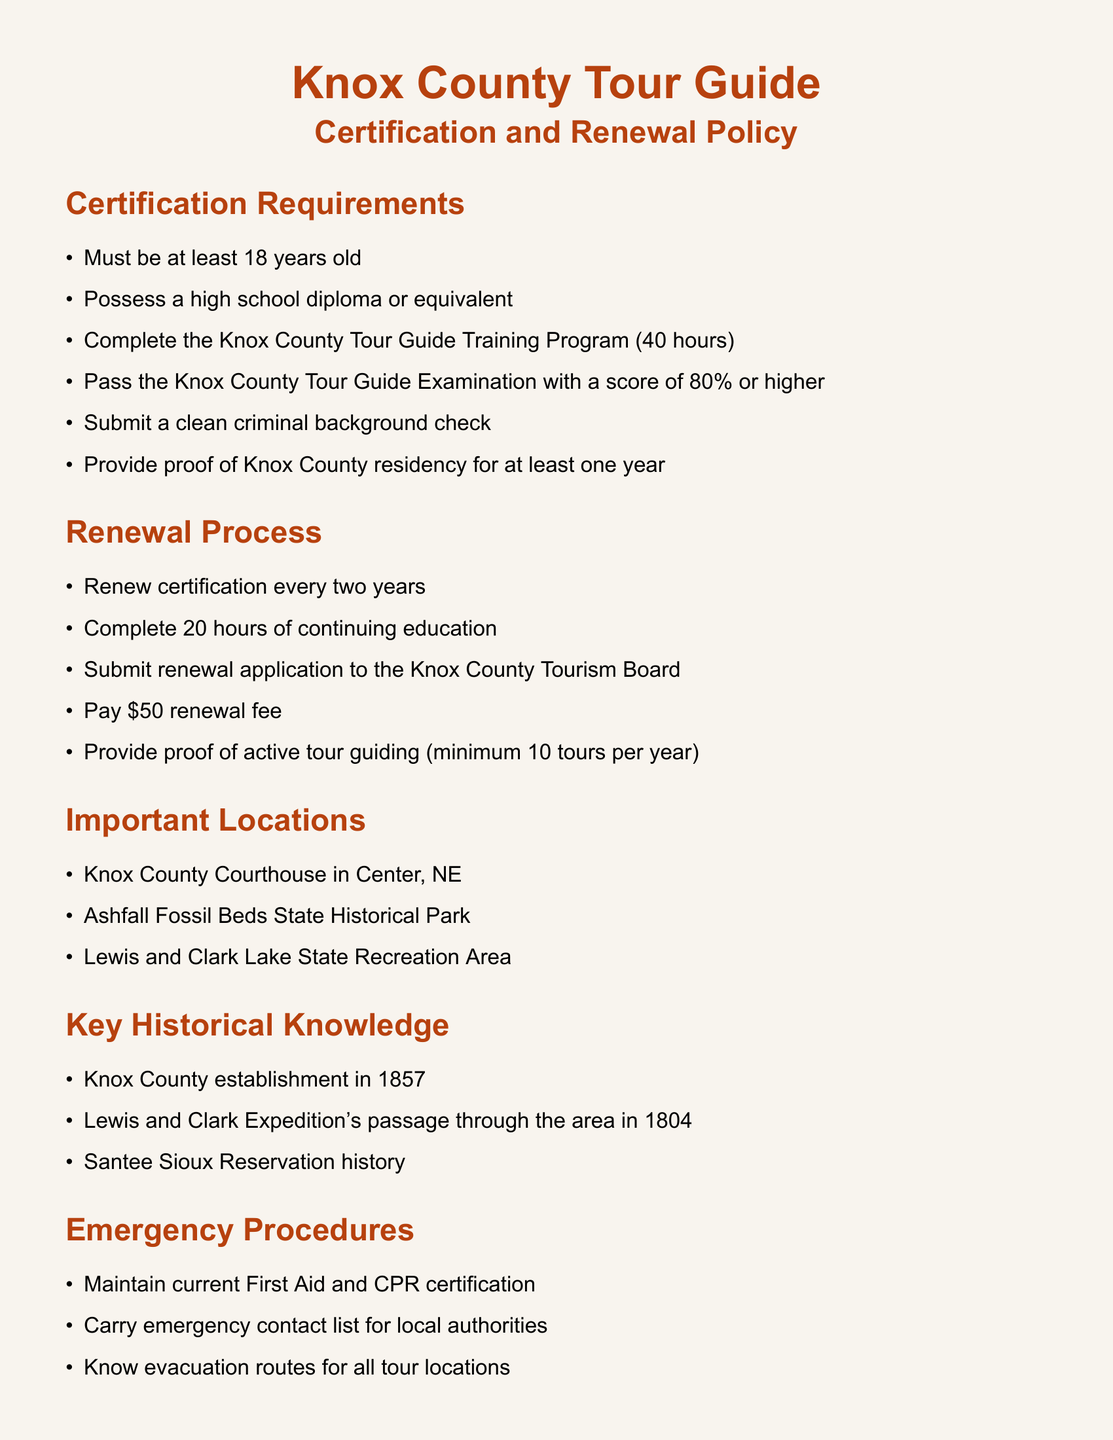What is the minimum age to become a certified tour guide? The document specifies that the individual must be at least 18 years old to meet certification requirements.
Answer: 18 years old How many hours is the Knox County Tour Guide Training Program? The certification requires completion of a 40-hour training program.
Answer: 40 hours What is the renewal fee for the tour guide certification? The document states that a renewal application requires a payment of $50.
Answer: $50 How often must tour guides renew their certification? According to the document, the certification must be renewed every two years.
Answer: Every two years What is the minimum number of tours a guide must conduct per year to maintain active status? The document stipulates that tour guides must conduct a minimum of 10 tours per year to be considered active.
Answer: 10 tours What year was Knox County established? The document indicates that Knox County was established in 1857.
Answer: 1857 What emergency certification must tour guides maintain? The document mentions that tour guides should maintain current First Aid and CPR certification in case of emergencies.
Answer: First Aid and CPR What is a key ethical guideline for tour guides? The document highlights providing accurate and unbiased information as a core ethical guideline.
Answer: Accurate and unbiased information 